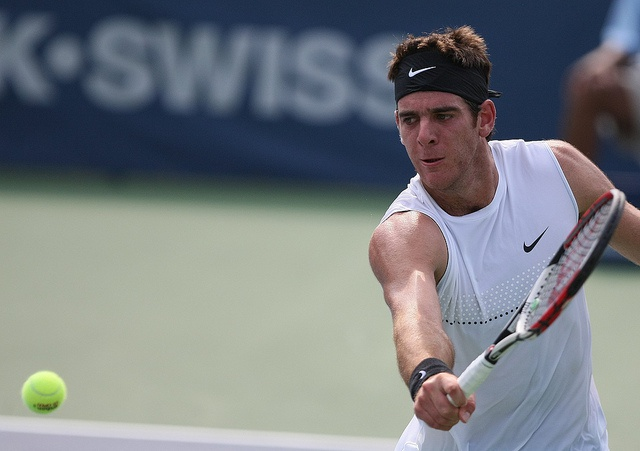Describe the objects in this image and their specific colors. I can see people in black, darkgray, and brown tones, people in black and gray tones, tennis racket in black, darkgray, gray, and lightgray tones, and sports ball in black, lightgreen, khaki, and darkgreen tones in this image. 